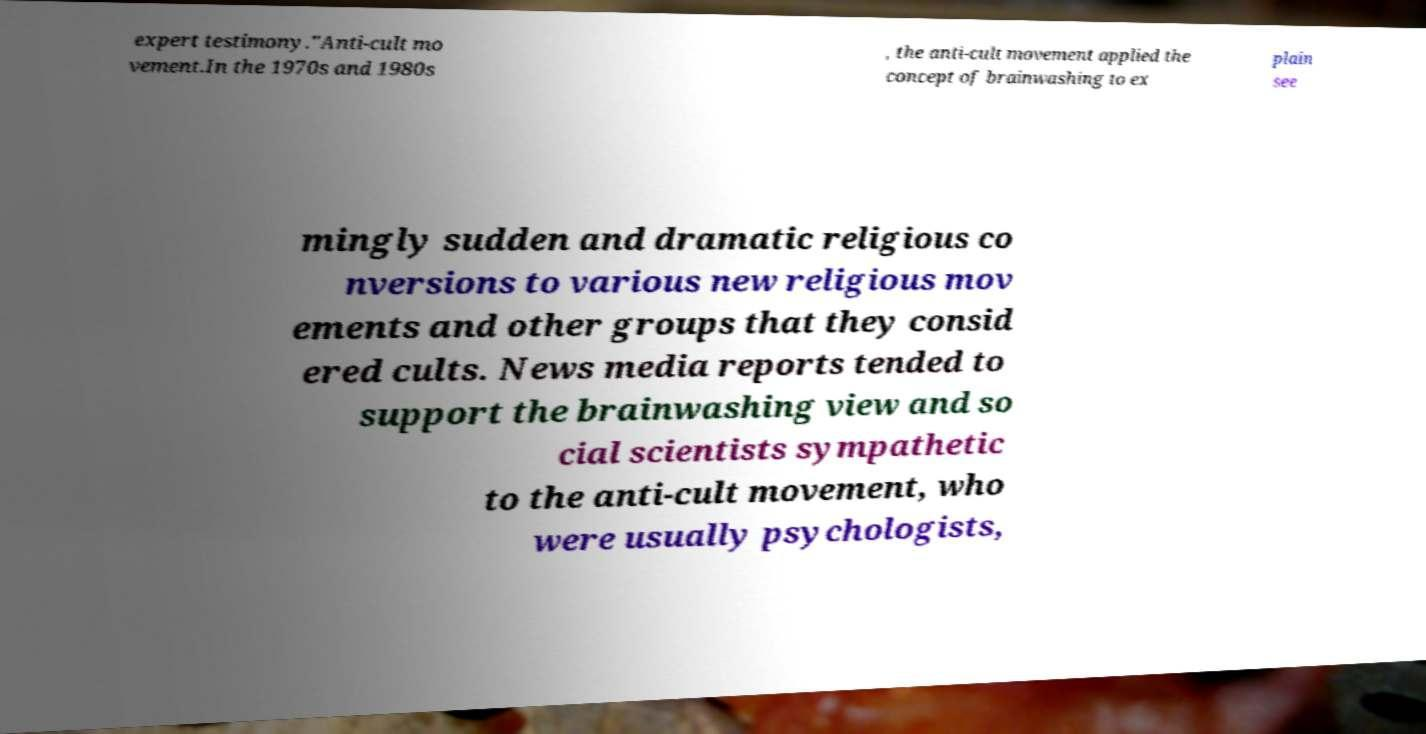For documentation purposes, I need the text within this image transcribed. Could you provide that? expert testimony."Anti-cult mo vement.In the 1970s and 1980s , the anti-cult movement applied the concept of brainwashing to ex plain see mingly sudden and dramatic religious co nversions to various new religious mov ements and other groups that they consid ered cults. News media reports tended to support the brainwashing view and so cial scientists sympathetic to the anti-cult movement, who were usually psychologists, 